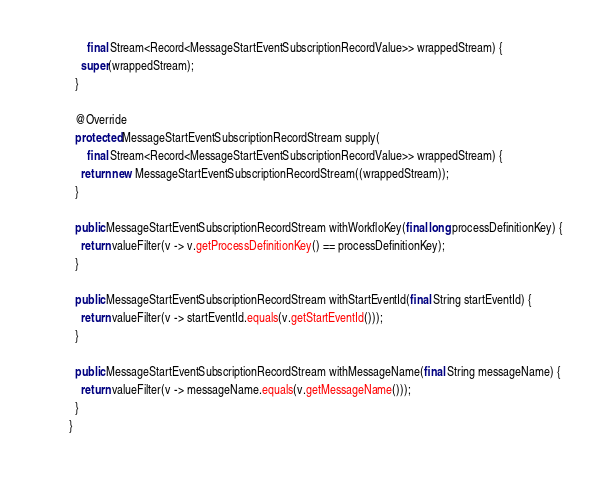Convert code to text. <code><loc_0><loc_0><loc_500><loc_500><_Java_>      final Stream<Record<MessageStartEventSubscriptionRecordValue>> wrappedStream) {
    super(wrappedStream);
  }

  @Override
  protected MessageStartEventSubscriptionRecordStream supply(
      final Stream<Record<MessageStartEventSubscriptionRecordValue>> wrappedStream) {
    return new MessageStartEventSubscriptionRecordStream((wrappedStream));
  }

  public MessageStartEventSubscriptionRecordStream withWorkfloKey(final long processDefinitionKey) {
    return valueFilter(v -> v.getProcessDefinitionKey() == processDefinitionKey);
  }

  public MessageStartEventSubscriptionRecordStream withStartEventId(final String startEventId) {
    return valueFilter(v -> startEventId.equals(v.getStartEventId()));
  }

  public MessageStartEventSubscriptionRecordStream withMessageName(final String messageName) {
    return valueFilter(v -> messageName.equals(v.getMessageName()));
  }
}
</code> 